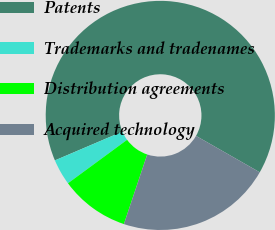Convert chart. <chart><loc_0><loc_0><loc_500><loc_500><pie_chart><fcel>Patents<fcel>Trademarks and tradenames<fcel>Distribution agreements<fcel>Acquired technology<nl><fcel>64.69%<fcel>3.67%<fcel>9.77%<fcel>21.88%<nl></chart> 